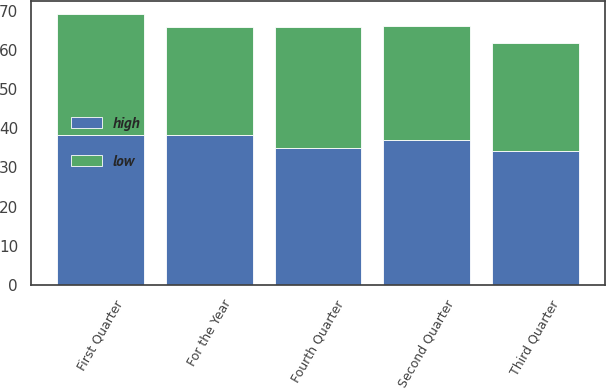Convert chart. <chart><loc_0><loc_0><loc_500><loc_500><stacked_bar_chart><ecel><fcel>First Quarter<fcel>Second Quarter<fcel>Third Quarter<fcel>Fourth Quarter<fcel>For the Year<nl><fcel>high<fcel>38.3<fcel>36.99<fcel>34.24<fcel>35.1<fcel>38.3<nl><fcel>low<fcel>30.87<fcel>29.3<fcel>27.49<fcel>30.92<fcel>27.49<nl></chart> 